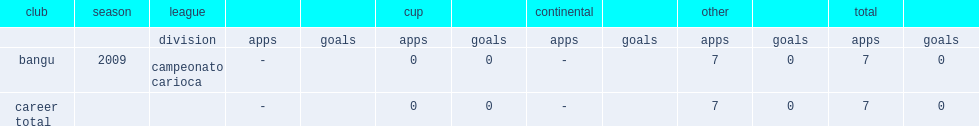Would you mind parsing the complete table? {'header': ['club', 'season', 'league', '', '', 'cup', '', 'continental', '', 'other', '', 'total', ''], 'rows': [['', '', 'division', 'apps', 'goals', 'apps', 'goals', 'apps', 'goals', 'apps', 'goals', 'apps', 'goals'], ['bangu', '2009', 'campeonato carioca', '-', '', '0', '0', '-', '', '7', '0', '7', '0'], ['career total', '', '', '-', '', '0', '0', '-', '', '7', '0', '7', '0']]} Which club did rodrigo melo playd for in 2009? Bangu. 